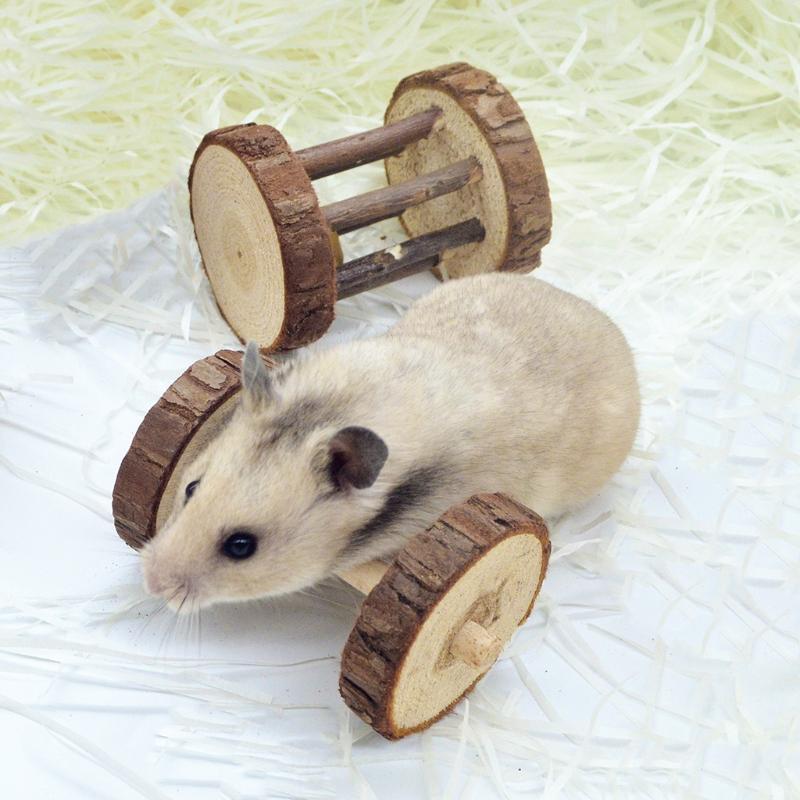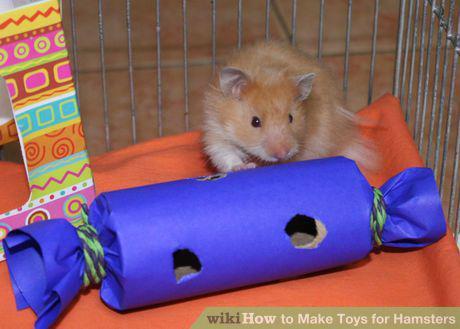The first image is the image on the left, the second image is the image on the right. Assess this claim about the two images: "There is at least one human hand touching a rodent.". Correct or not? Answer yes or no. No. The first image is the image on the left, the second image is the image on the right. Assess this claim about the two images: "An item perforated with a hole is touched by a rodent standing behind it, in one image.". Correct or not? Answer yes or no. Yes. 